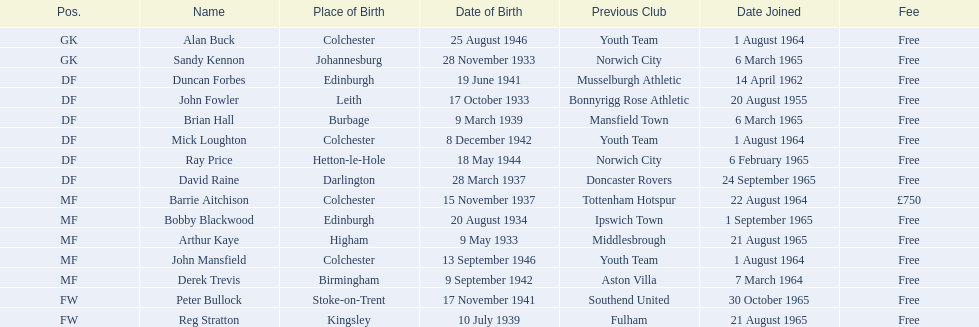What is the number of players categorized as df? 6. 